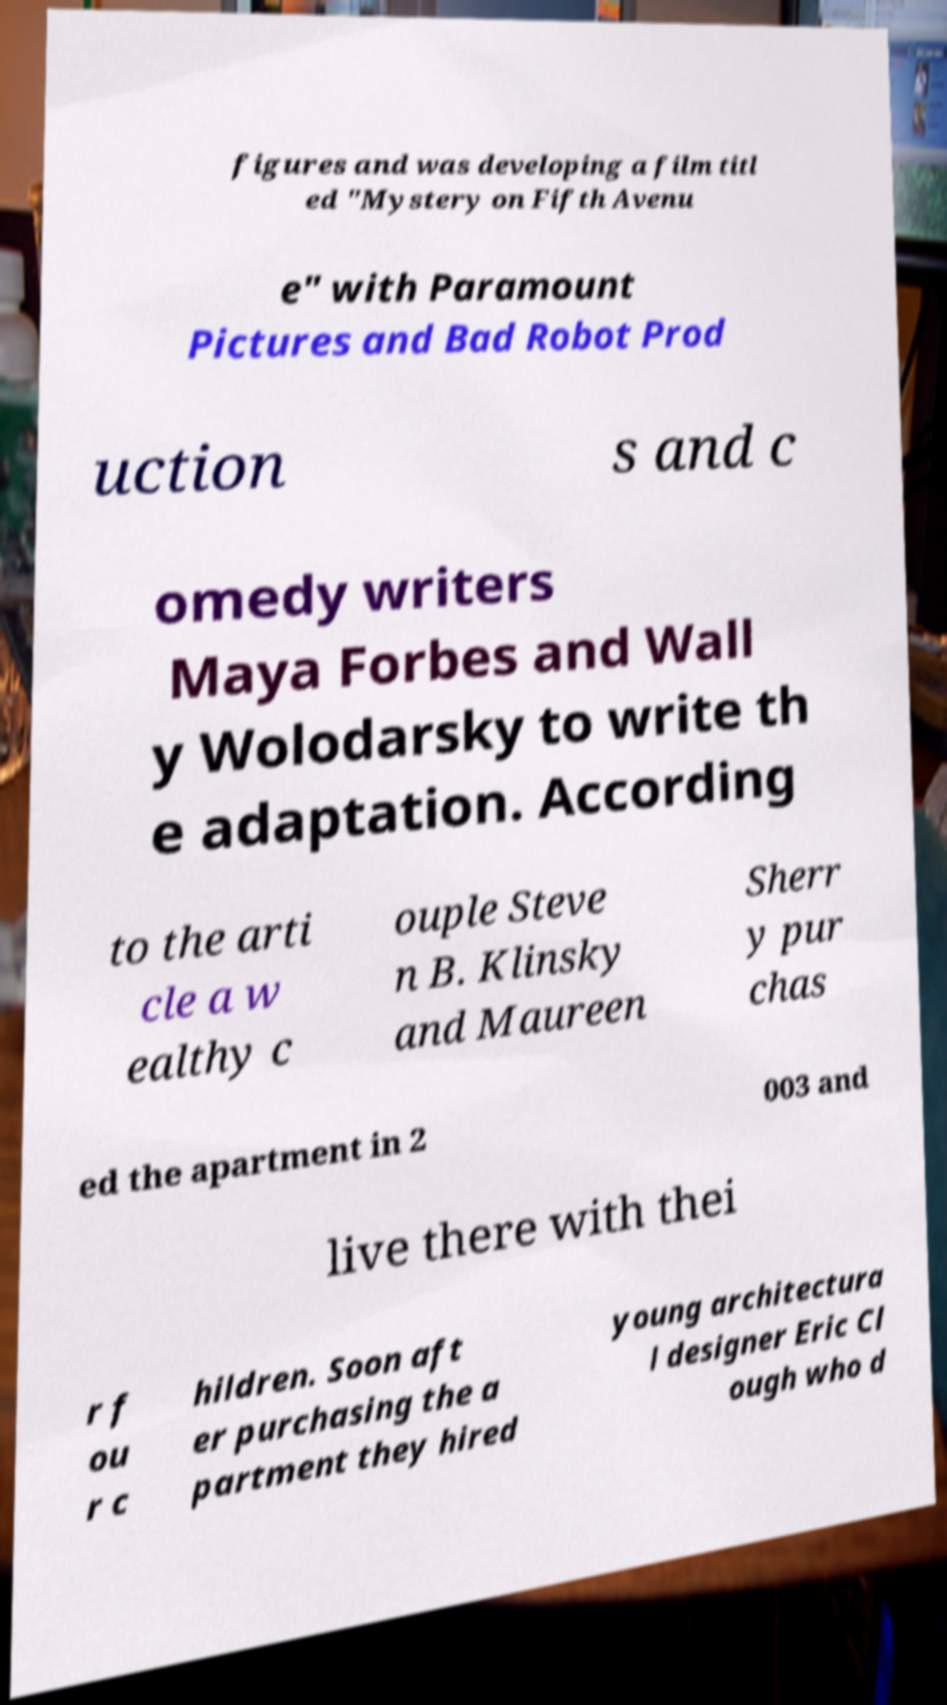Could you extract and type out the text from this image? figures and was developing a film titl ed "Mystery on Fifth Avenu e" with Paramount Pictures and Bad Robot Prod uction s and c omedy writers Maya Forbes and Wall y Wolodarsky to write th e adaptation. According to the arti cle a w ealthy c ouple Steve n B. Klinsky and Maureen Sherr y pur chas ed the apartment in 2 003 and live there with thei r f ou r c hildren. Soon aft er purchasing the a partment they hired young architectura l designer Eric Cl ough who d 